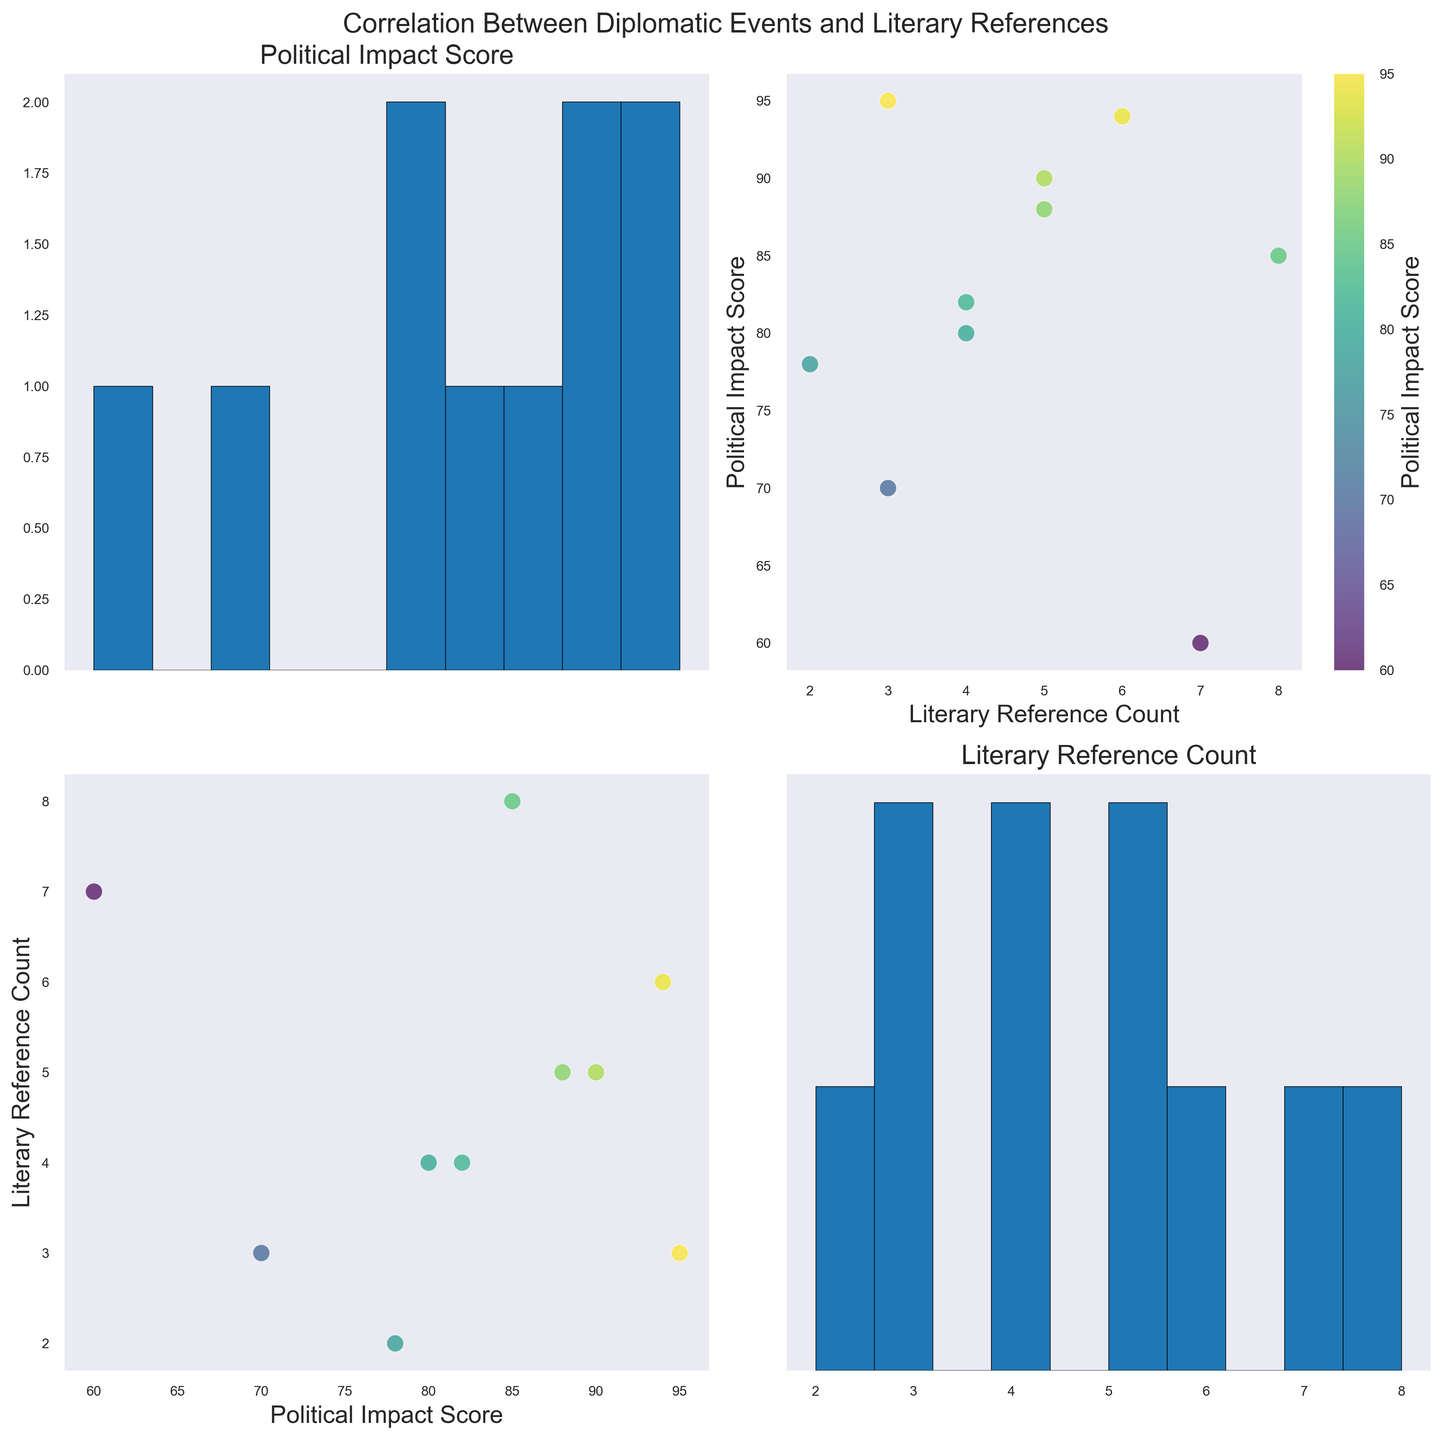What is the title of the scatter plot matrix (SPLOM)? The title is usually located at the top of the figure. It helps to orient the viewer to the topic or focus of the visualized data.
Answer: Correlation Between Diplomatic Events and Literary References How many variables are visualized in the scatter plot matrix? Each of the scatter plot matrix's axes is labeled with a variable. Count the unique variables labeled on both axes.
Answer: 2 Which memoir has the highest Literary Reference Count? Identify the dot in the scatter plot with the highest y-axis value for Literary Reference Count and trace it back to its corresponding memoir.
Answer: Keeping Faith What are the Political Impact Score and Literary Reference Count for the 'End of Apartheid' event? Find the point corresponding to 'End of Apartheid' and note its x (Political Impact Score) and y (Literary Reference Count) values.
Answer: 94, 6 Compare the Political Impact Score between the 'Cuban Missile Crisis' and 'Rwanda Genocide'. Which has a higher score? Locate the points for both events on the Political Impact Score axis and compare their scores.
Answer: Cuban Missile Crisis Is there a positive correlation between Political Impact Score and Literary Reference Count? Examine the scatter plots between these two variables. A positive correlation is indicated if points trend upward from left to right.
Answer: No What's the average Political Impact Score across all events? Sum all the Political Impact Scores and divide by the number of events. The scores are: 90, 85, 95, 80, 94, 78, 60, 88, 82, 70.
Answer: (90+85+95+80+94+78+60+88+82+70)/10 = 82.2 For the 'Syria Chemical Attack', what's the difference between the Political Impact Score and Literary Reference Count? Subtract the Literary Reference Count from the Political Impact Score for 'Syria Chemical Attack'.
Answer: 70 - 3 = 67 What is the most common range for Literary Reference Count as seen in the histogram? Looking at the histogram plot for Literary Reference Count, identify the range with the highest frequency. This is usually the tallest bar.
Answer: 0-2 